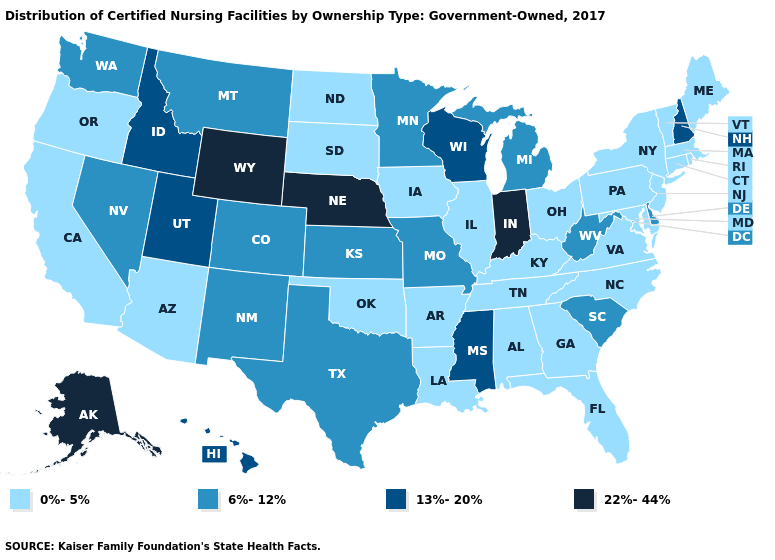Among the states that border Missouri , does Nebraska have the highest value?
Be succinct. Yes. Among the states that border Arkansas , does Oklahoma have the highest value?
Be succinct. No. What is the lowest value in states that border Indiana?
Give a very brief answer. 0%-5%. What is the value of Massachusetts?
Concise answer only. 0%-5%. Name the states that have a value in the range 6%-12%?
Quick response, please. Colorado, Delaware, Kansas, Michigan, Minnesota, Missouri, Montana, Nevada, New Mexico, South Carolina, Texas, Washington, West Virginia. Among the states that border Arkansas , which have the lowest value?
Concise answer only. Louisiana, Oklahoma, Tennessee. Does South Carolina have the highest value in the South?
Answer briefly. No. What is the lowest value in the West?
Short answer required. 0%-5%. What is the value of Idaho?
Write a very short answer. 13%-20%. Does Mississippi have the same value as Hawaii?
Concise answer only. Yes. Which states have the highest value in the USA?
Short answer required. Alaska, Indiana, Nebraska, Wyoming. Among the states that border Michigan , does Wisconsin have the lowest value?
Write a very short answer. No. Which states have the lowest value in the West?
Write a very short answer. Arizona, California, Oregon. What is the value of Massachusetts?
Short answer required. 0%-5%. What is the value of California?
Short answer required. 0%-5%. 